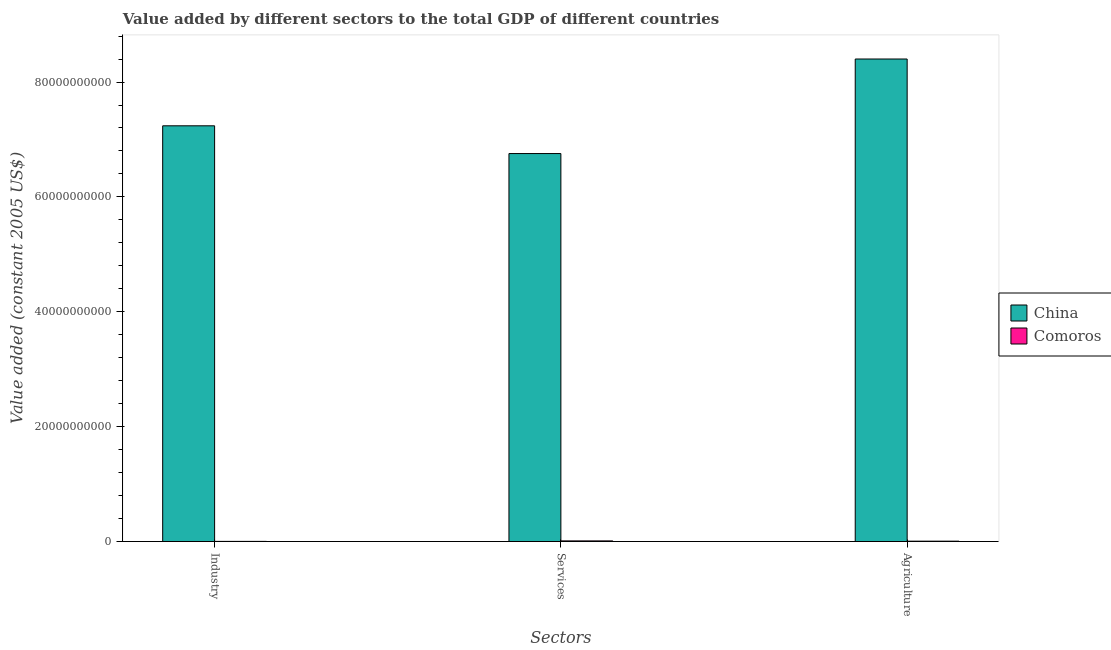How many groups of bars are there?
Offer a very short reply. 3. Are the number of bars per tick equal to the number of legend labels?
Your answer should be compact. Yes. Are the number of bars on each tick of the X-axis equal?
Your answer should be very brief. Yes. How many bars are there on the 1st tick from the left?
Your response must be concise. 2. What is the label of the 2nd group of bars from the left?
Offer a very short reply. Services. What is the value added by industrial sector in China?
Provide a succinct answer. 7.24e+1. Across all countries, what is the maximum value added by industrial sector?
Give a very brief answer. 7.24e+1. Across all countries, what is the minimum value added by services?
Your response must be concise. 1.15e+08. In which country was the value added by industrial sector maximum?
Keep it short and to the point. China. In which country was the value added by industrial sector minimum?
Make the answer very short. Comoros. What is the total value added by agricultural sector in the graph?
Offer a terse response. 8.41e+1. What is the difference between the value added by agricultural sector in Comoros and that in China?
Provide a succinct answer. -8.39e+1. What is the difference between the value added by services in China and the value added by agricultural sector in Comoros?
Your answer should be compact. 6.75e+1. What is the average value added by agricultural sector per country?
Provide a short and direct response. 4.20e+1. What is the difference between the value added by industrial sector and value added by services in China?
Provide a succinct answer. 4.83e+09. What is the ratio of the value added by services in Comoros to that in China?
Provide a short and direct response. 0. What is the difference between the highest and the second highest value added by agricultural sector?
Provide a short and direct response. 8.39e+1. What is the difference between the highest and the lowest value added by services?
Provide a short and direct response. 6.74e+1. In how many countries, is the value added by agricultural sector greater than the average value added by agricultural sector taken over all countries?
Offer a terse response. 1. Is the sum of the value added by services in China and Comoros greater than the maximum value added by industrial sector across all countries?
Give a very brief answer. No. What does the 2nd bar from the left in Services represents?
Your answer should be compact. Comoros. What does the 2nd bar from the right in Services represents?
Offer a very short reply. China. How many bars are there?
Your response must be concise. 6. Are all the bars in the graph horizontal?
Keep it short and to the point. No. How many countries are there in the graph?
Offer a very short reply. 2. What is the difference between two consecutive major ticks on the Y-axis?
Offer a terse response. 2.00e+1. How many legend labels are there?
Your answer should be very brief. 2. What is the title of the graph?
Keep it short and to the point. Value added by different sectors to the total GDP of different countries. Does "Equatorial Guinea" appear as one of the legend labels in the graph?
Your answer should be very brief. No. What is the label or title of the X-axis?
Your response must be concise. Sectors. What is the label or title of the Y-axis?
Offer a very short reply. Value added (constant 2005 US$). What is the Value added (constant 2005 US$) in China in Industry?
Offer a terse response. 7.24e+1. What is the Value added (constant 2005 US$) in Comoros in Industry?
Provide a succinct answer. 3.00e+07. What is the Value added (constant 2005 US$) in China in Services?
Offer a terse response. 6.75e+1. What is the Value added (constant 2005 US$) of Comoros in Services?
Your response must be concise. 1.15e+08. What is the Value added (constant 2005 US$) of China in Agriculture?
Offer a terse response. 8.40e+1. What is the Value added (constant 2005 US$) in Comoros in Agriculture?
Your response must be concise. 6.80e+07. Across all Sectors, what is the maximum Value added (constant 2005 US$) in China?
Offer a terse response. 8.40e+1. Across all Sectors, what is the maximum Value added (constant 2005 US$) of Comoros?
Keep it short and to the point. 1.15e+08. Across all Sectors, what is the minimum Value added (constant 2005 US$) of China?
Your answer should be compact. 6.75e+1. Across all Sectors, what is the minimum Value added (constant 2005 US$) in Comoros?
Your response must be concise. 3.00e+07. What is the total Value added (constant 2005 US$) of China in the graph?
Your answer should be very brief. 2.24e+11. What is the total Value added (constant 2005 US$) of Comoros in the graph?
Your response must be concise. 2.13e+08. What is the difference between the Value added (constant 2005 US$) in China in Industry and that in Services?
Offer a very short reply. 4.83e+09. What is the difference between the Value added (constant 2005 US$) of Comoros in Industry and that in Services?
Your answer should be very brief. -8.53e+07. What is the difference between the Value added (constant 2005 US$) in China in Industry and that in Agriculture?
Your answer should be compact. -1.16e+1. What is the difference between the Value added (constant 2005 US$) of Comoros in Industry and that in Agriculture?
Provide a succinct answer. -3.80e+07. What is the difference between the Value added (constant 2005 US$) in China in Services and that in Agriculture?
Ensure brevity in your answer.  -1.65e+1. What is the difference between the Value added (constant 2005 US$) in Comoros in Services and that in Agriculture?
Offer a terse response. 4.73e+07. What is the difference between the Value added (constant 2005 US$) of China in Industry and the Value added (constant 2005 US$) of Comoros in Services?
Offer a very short reply. 7.23e+1. What is the difference between the Value added (constant 2005 US$) of China in Industry and the Value added (constant 2005 US$) of Comoros in Agriculture?
Your answer should be very brief. 7.23e+1. What is the difference between the Value added (constant 2005 US$) in China in Services and the Value added (constant 2005 US$) in Comoros in Agriculture?
Keep it short and to the point. 6.75e+1. What is the average Value added (constant 2005 US$) of China per Sectors?
Ensure brevity in your answer.  7.46e+1. What is the average Value added (constant 2005 US$) of Comoros per Sectors?
Give a very brief answer. 7.11e+07. What is the difference between the Value added (constant 2005 US$) of China and Value added (constant 2005 US$) of Comoros in Industry?
Ensure brevity in your answer.  7.24e+1. What is the difference between the Value added (constant 2005 US$) in China and Value added (constant 2005 US$) in Comoros in Services?
Provide a succinct answer. 6.74e+1. What is the difference between the Value added (constant 2005 US$) of China and Value added (constant 2005 US$) of Comoros in Agriculture?
Offer a very short reply. 8.39e+1. What is the ratio of the Value added (constant 2005 US$) in China in Industry to that in Services?
Make the answer very short. 1.07. What is the ratio of the Value added (constant 2005 US$) of Comoros in Industry to that in Services?
Give a very brief answer. 0.26. What is the ratio of the Value added (constant 2005 US$) of China in Industry to that in Agriculture?
Provide a succinct answer. 0.86. What is the ratio of the Value added (constant 2005 US$) of Comoros in Industry to that in Agriculture?
Your answer should be very brief. 0.44. What is the ratio of the Value added (constant 2005 US$) in China in Services to that in Agriculture?
Offer a terse response. 0.8. What is the ratio of the Value added (constant 2005 US$) of Comoros in Services to that in Agriculture?
Offer a very short reply. 1.7. What is the difference between the highest and the second highest Value added (constant 2005 US$) of China?
Your response must be concise. 1.16e+1. What is the difference between the highest and the second highest Value added (constant 2005 US$) of Comoros?
Give a very brief answer. 4.73e+07. What is the difference between the highest and the lowest Value added (constant 2005 US$) of China?
Provide a succinct answer. 1.65e+1. What is the difference between the highest and the lowest Value added (constant 2005 US$) of Comoros?
Your answer should be compact. 8.53e+07. 